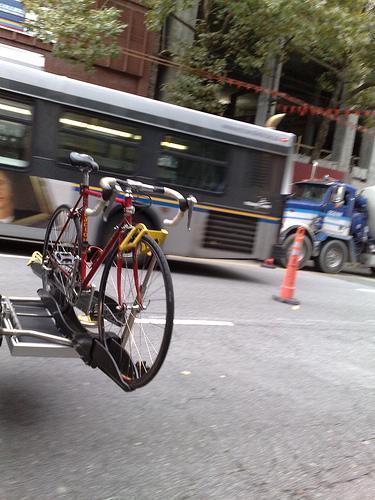How many cones are pictured?
Give a very brief answer. 1. How many bicycles are there?
Give a very brief answer. 1. 